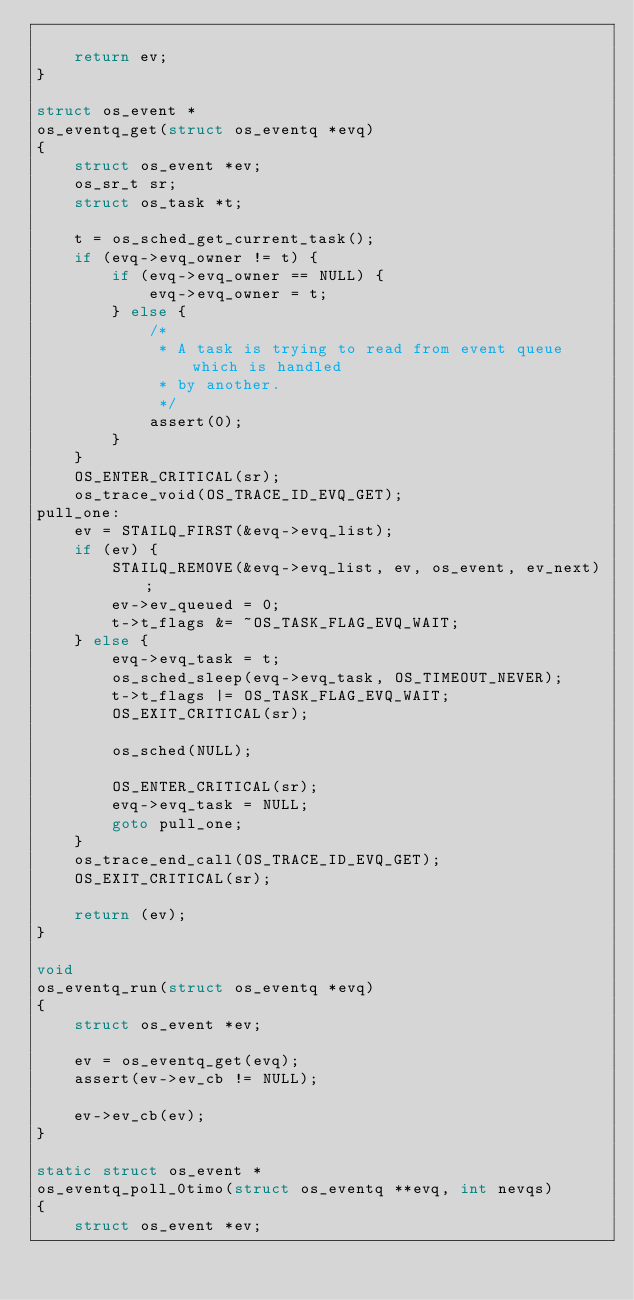<code> <loc_0><loc_0><loc_500><loc_500><_C_>
    return ev;
}

struct os_event *
os_eventq_get(struct os_eventq *evq)
{
    struct os_event *ev;
    os_sr_t sr;
    struct os_task *t;

    t = os_sched_get_current_task();
    if (evq->evq_owner != t) {
        if (evq->evq_owner == NULL) {
            evq->evq_owner = t;
        } else {
            /*
             * A task is trying to read from event queue which is handled
             * by another.
             */
            assert(0);
        }
    }
    OS_ENTER_CRITICAL(sr);
    os_trace_void(OS_TRACE_ID_EVQ_GET);
pull_one:
    ev = STAILQ_FIRST(&evq->evq_list);
    if (ev) {
        STAILQ_REMOVE(&evq->evq_list, ev, os_event, ev_next);
        ev->ev_queued = 0;
        t->t_flags &= ~OS_TASK_FLAG_EVQ_WAIT;
    } else {
        evq->evq_task = t;
        os_sched_sleep(evq->evq_task, OS_TIMEOUT_NEVER);
        t->t_flags |= OS_TASK_FLAG_EVQ_WAIT;
        OS_EXIT_CRITICAL(sr);

        os_sched(NULL);

        OS_ENTER_CRITICAL(sr);
        evq->evq_task = NULL;
        goto pull_one;
    }
    os_trace_end_call(OS_TRACE_ID_EVQ_GET);
    OS_EXIT_CRITICAL(sr);

    return (ev);
}

void
os_eventq_run(struct os_eventq *evq)
{
    struct os_event *ev;

    ev = os_eventq_get(evq);
    assert(ev->ev_cb != NULL);

    ev->ev_cb(ev);
}

static struct os_event *
os_eventq_poll_0timo(struct os_eventq **evq, int nevqs)
{
    struct os_event *ev;</code> 